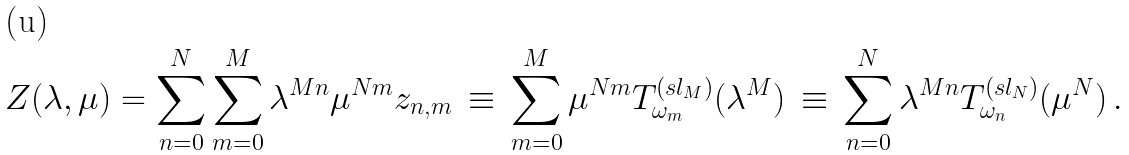<formula> <loc_0><loc_0><loc_500><loc_500>Z ( \lambda , \mu ) = \sum _ { n = 0 } ^ { N } \sum _ { m = 0 } ^ { M } \lambda ^ { M n } \mu ^ { N m } z _ { n , m } \, \equiv \, \sum _ { m = 0 } ^ { M } \mu ^ { N m } T _ { \omega _ { m } } ^ { ( s l _ { M } ) } ( \lambda ^ { M } ) \, \equiv \, \sum _ { n = 0 } ^ { N } \lambda ^ { M n } T _ { \omega _ { n } } ^ { ( s l _ { N } ) } ( \mu ^ { N } ) \, .</formula> 